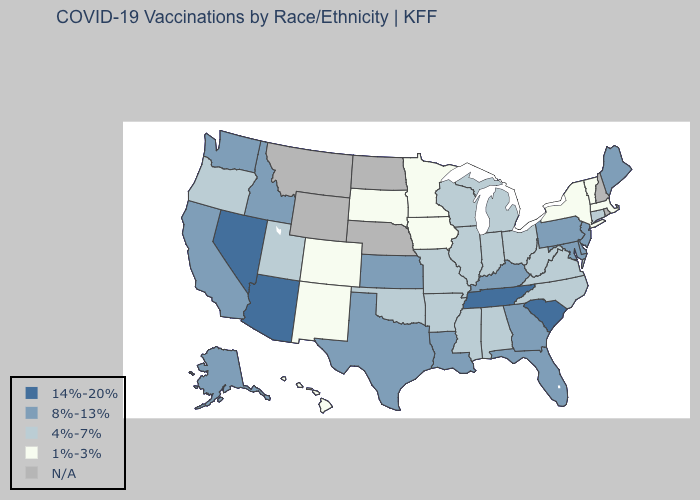Which states hav the highest value in the South?
Short answer required. South Carolina, Tennessee. Which states have the highest value in the USA?
Short answer required. Arizona, Nevada, South Carolina, Tennessee. What is the value of Louisiana?
Answer briefly. 8%-13%. Name the states that have a value in the range N/A?
Answer briefly. Montana, Nebraska, New Hampshire, North Dakota, Rhode Island, Wyoming. Name the states that have a value in the range 14%-20%?
Short answer required. Arizona, Nevada, South Carolina, Tennessee. Name the states that have a value in the range 8%-13%?
Give a very brief answer. Alaska, California, Delaware, Florida, Georgia, Idaho, Kansas, Kentucky, Louisiana, Maine, Maryland, New Jersey, Pennsylvania, Texas, Washington. What is the lowest value in the USA?
Answer briefly. 1%-3%. What is the value of New Jersey?
Keep it brief. 8%-13%. What is the lowest value in states that border Indiana?
Short answer required. 4%-7%. What is the lowest value in the USA?
Quick response, please. 1%-3%. Name the states that have a value in the range 4%-7%?
Write a very short answer. Alabama, Arkansas, Connecticut, Illinois, Indiana, Michigan, Mississippi, Missouri, North Carolina, Ohio, Oklahoma, Oregon, Utah, Virginia, West Virginia, Wisconsin. Name the states that have a value in the range 1%-3%?
Give a very brief answer. Colorado, Hawaii, Iowa, Massachusetts, Minnesota, New Mexico, New York, South Dakota, Vermont. Name the states that have a value in the range 4%-7%?
Keep it brief. Alabama, Arkansas, Connecticut, Illinois, Indiana, Michigan, Mississippi, Missouri, North Carolina, Ohio, Oklahoma, Oregon, Utah, Virginia, West Virginia, Wisconsin. How many symbols are there in the legend?
Short answer required. 5. Does the first symbol in the legend represent the smallest category?
Short answer required. No. 